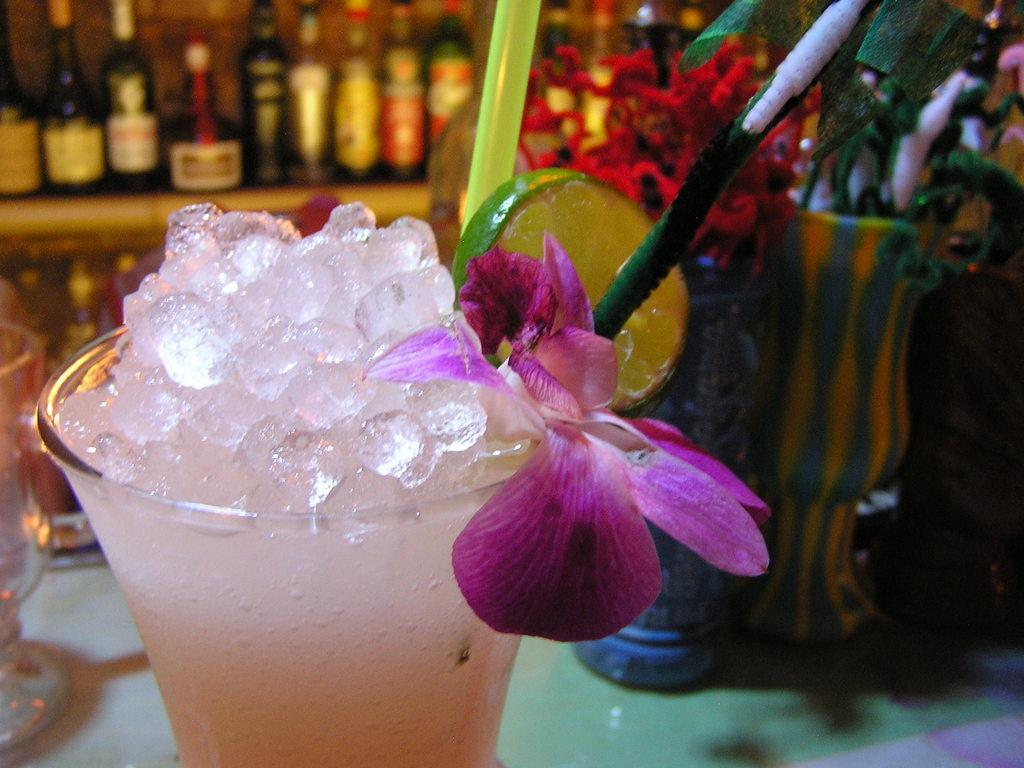Could you give a brief overview of what you see in this image? In the picture we can see a glass with ice pieces and flower which is pink in color and a straw in it and beside it, we can see a lemon slice and inside the glass we can see some flower vase with some flowers and plants and in the background we can see a rack with wine bottles in it. 